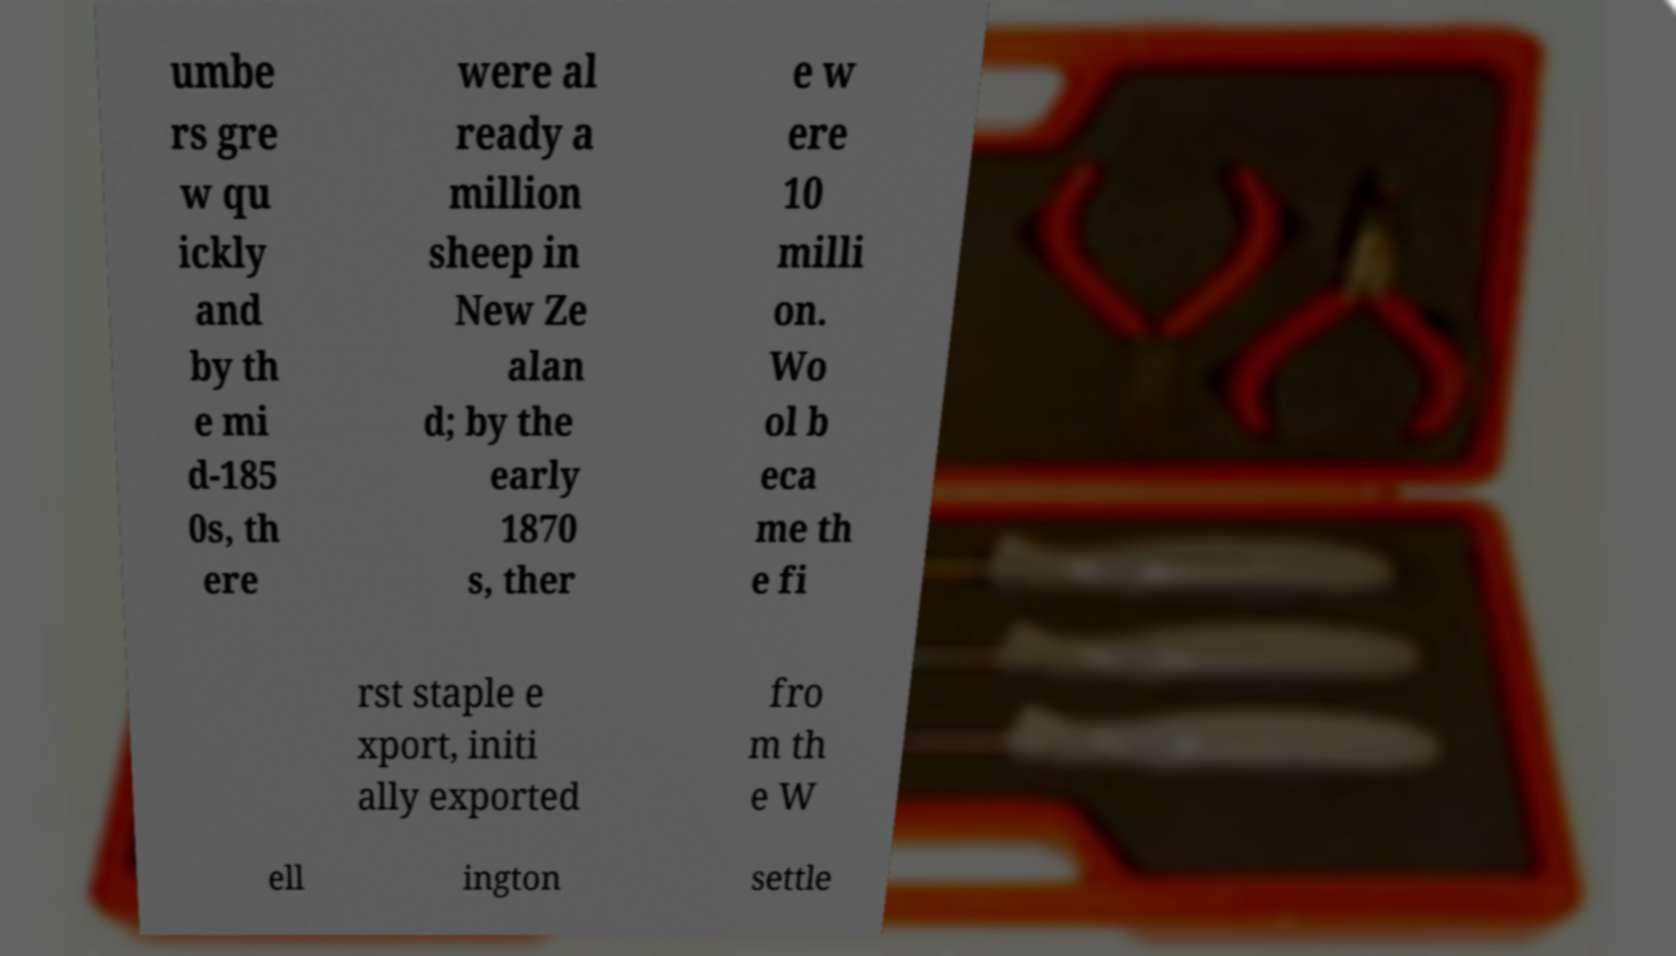What messages or text are displayed in this image? I need them in a readable, typed format. umbe rs gre w qu ickly and by th e mi d-185 0s, th ere were al ready a million sheep in New Ze alan d; by the early 1870 s, ther e w ere 10 milli on. Wo ol b eca me th e fi rst staple e xport, initi ally exported fro m th e W ell ington settle 